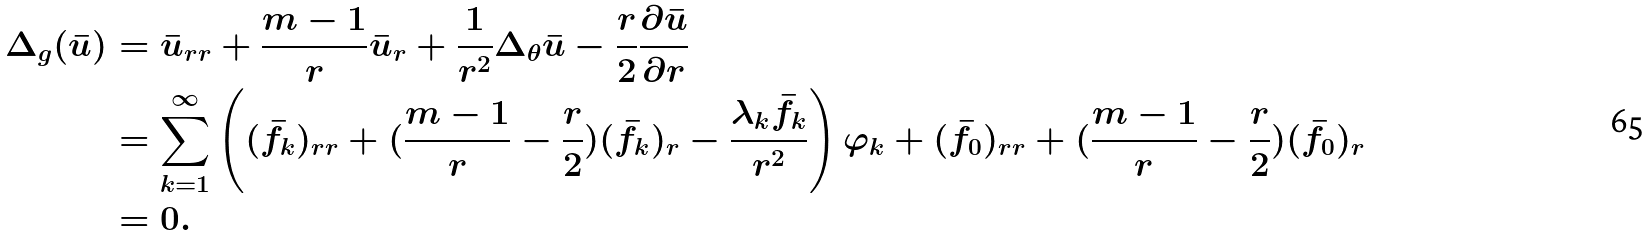<formula> <loc_0><loc_0><loc_500><loc_500>\Delta _ { g } ( \bar { u } ) & = \bar { u } _ { r r } + \frac { m - 1 } { r } \bar { u } _ { r } + \frac { 1 } { r ^ { 2 } } \Delta _ { \theta } \bar { u } - \frac { r } { 2 } \frac { \partial \bar { u } } { \partial r } \\ & = \sum _ { k = 1 } ^ { \infty } \left ( ( \bar { f } _ { k } ) _ { r r } + ( \frac { m - 1 } { r } - \frac { r } { 2 } ) ( \bar { f } _ { k } ) _ { r } - \frac { \lambda _ { k } \bar { f } _ { k } } { r ^ { 2 } } \right ) \varphi _ { k } + ( \bar { f } _ { 0 } ) _ { r r } + ( \frac { m - 1 } { r } - \frac { r } { 2 } ) ( \bar { f } _ { 0 } ) _ { r } \\ & = 0 .</formula> 